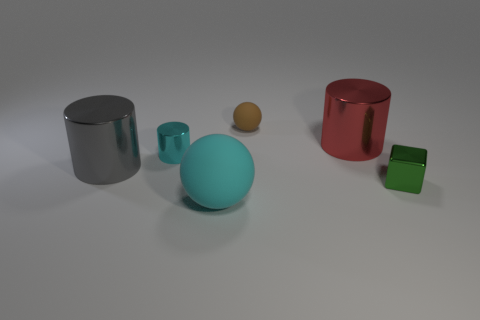The small metal object that is behind the tiny shiny thing that is on the right side of the rubber sphere that is behind the cyan rubber thing is what shape?
Ensure brevity in your answer.  Cylinder. Is the tiny cylinder the same color as the big ball?
Offer a terse response. Yes. Are there more green shiny objects than red rubber objects?
Offer a very short reply. Yes. How many other objects are there of the same material as the big cyan sphere?
Offer a very short reply. 1. What number of things are green balls or rubber balls that are behind the green metallic cube?
Your response must be concise. 1. Are there fewer red metal cylinders than objects?
Keep it short and to the point. Yes. There is a big shiny cylinder that is in front of the large thing that is right of the object that is in front of the tiny metal block; what color is it?
Make the answer very short. Gray. Are the brown thing and the big cyan object made of the same material?
Provide a succinct answer. Yes. There is a brown rubber ball; what number of things are in front of it?
Provide a short and direct response. 5. There is another matte object that is the same shape as the big cyan object; what is its size?
Offer a terse response. Small. 